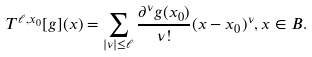Convert formula to latex. <formula><loc_0><loc_0><loc_500><loc_500>T ^ { \ell , x _ { 0 } } [ g ] ( x ) = \sum _ { | \nu | \leq \ell } \frac { \partial ^ { \nu } g ( x _ { 0 } ) } { \nu ! } ( x - x _ { 0 } ) ^ { \nu } , x \in B .</formula> 